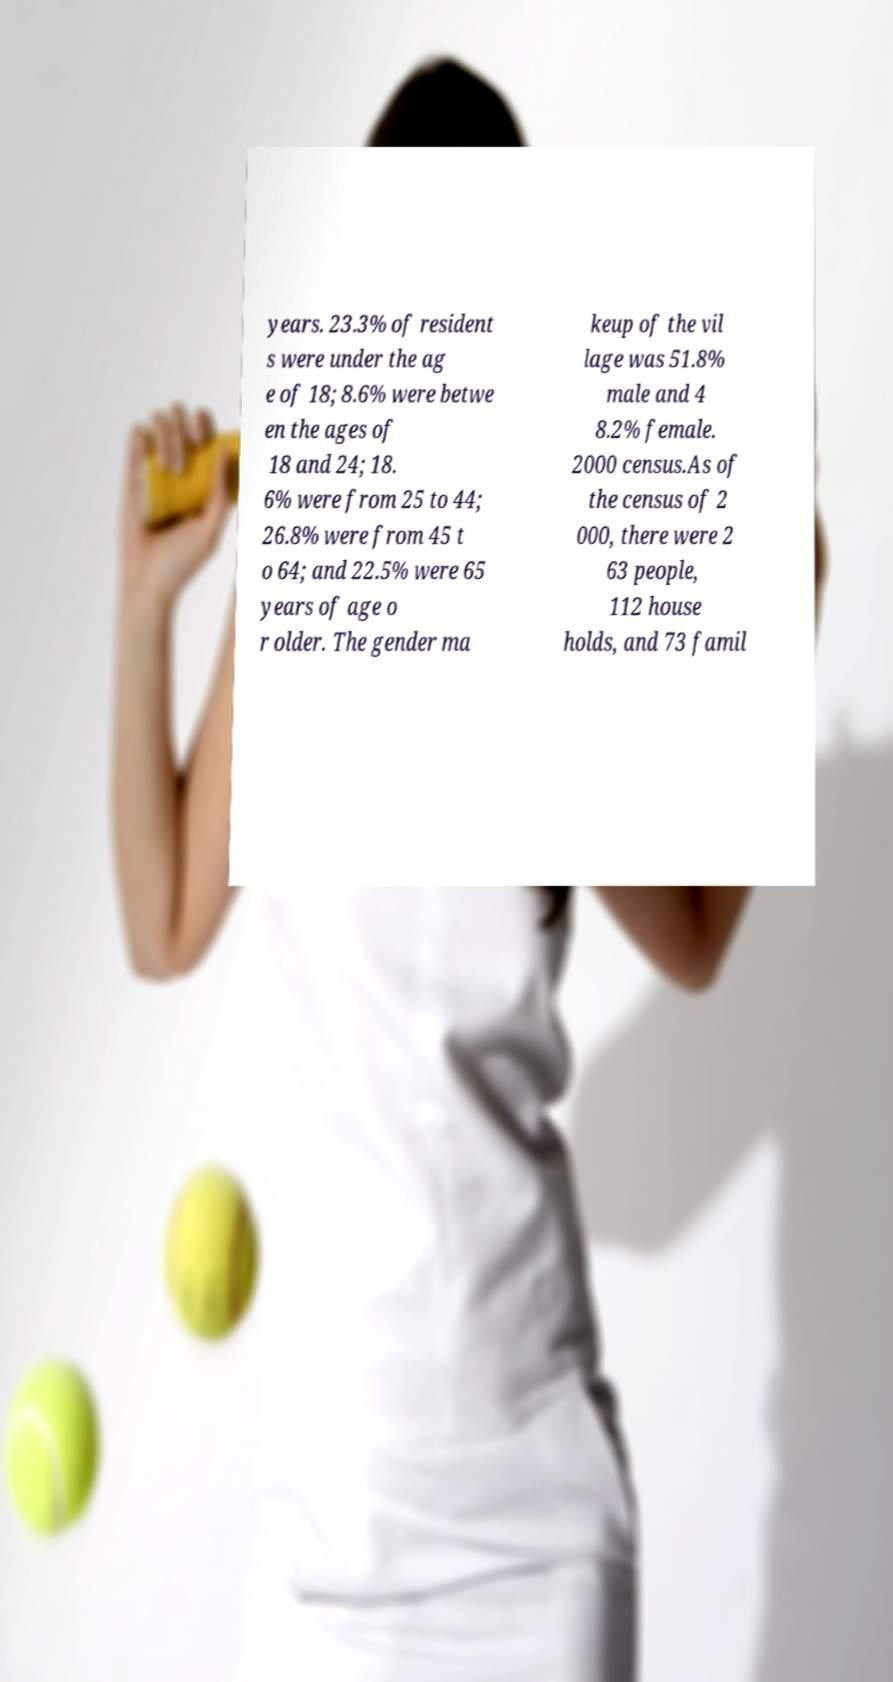Please read and relay the text visible in this image. What does it say? years. 23.3% of resident s were under the ag e of 18; 8.6% were betwe en the ages of 18 and 24; 18. 6% were from 25 to 44; 26.8% were from 45 t o 64; and 22.5% were 65 years of age o r older. The gender ma keup of the vil lage was 51.8% male and 4 8.2% female. 2000 census.As of the census of 2 000, there were 2 63 people, 112 house holds, and 73 famil 